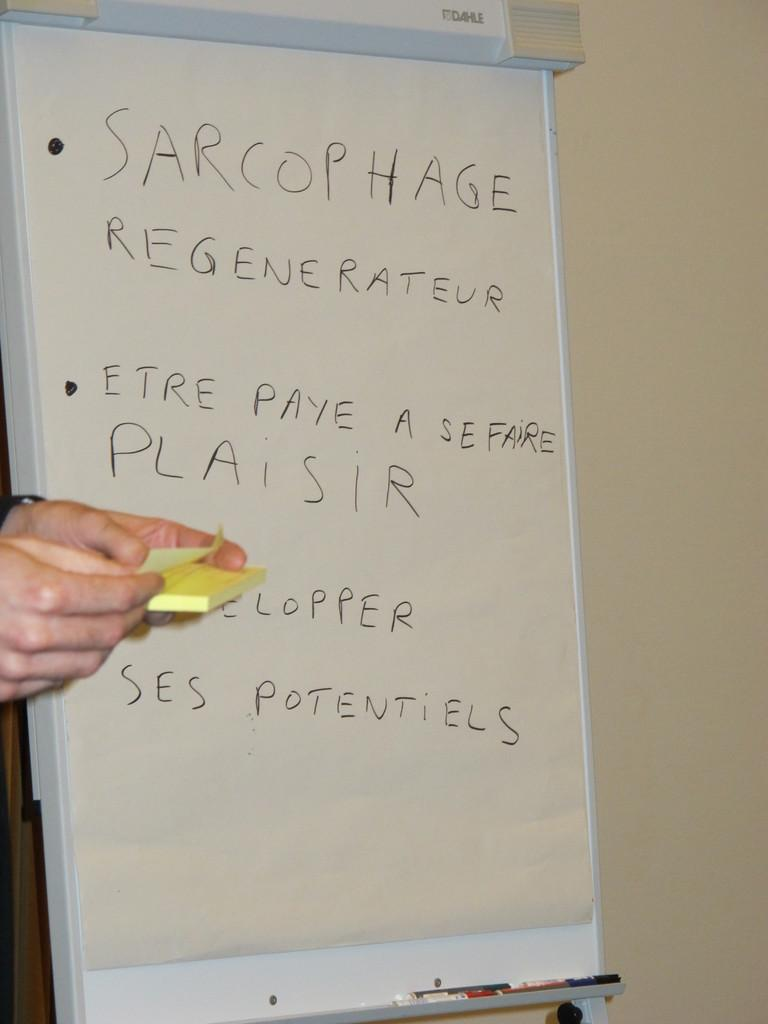<image>
Share a concise interpretation of the image provided. An easel pad has Sarcophage written in large letters at the top. 